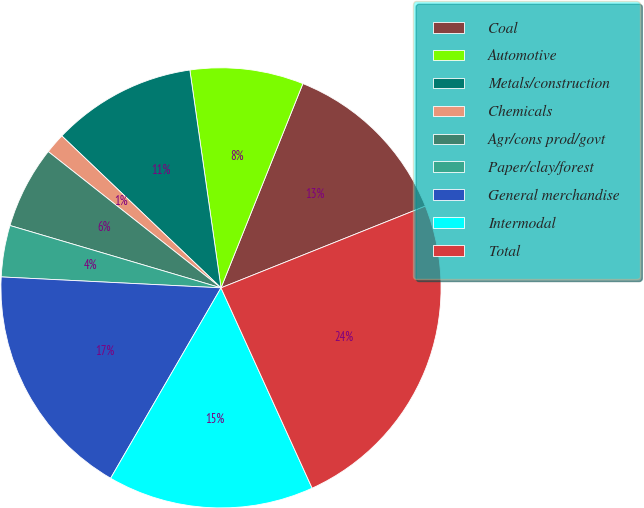Convert chart to OTSL. <chart><loc_0><loc_0><loc_500><loc_500><pie_chart><fcel>Coal<fcel>Automotive<fcel>Metals/construction<fcel>Chemicals<fcel>Agr/cons prod/govt<fcel>Paper/clay/forest<fcel>General merchandise<fcel>Intermodal<fcel>Total<nl><fcel>12.88%<fcel>8.33%<fcel>10.61%<fcel>1.5%<fcel>6.06%<fcel>3.78%<fcel>17.43%<fcel>15.16%<fcel>24.26%<nl></chart> 